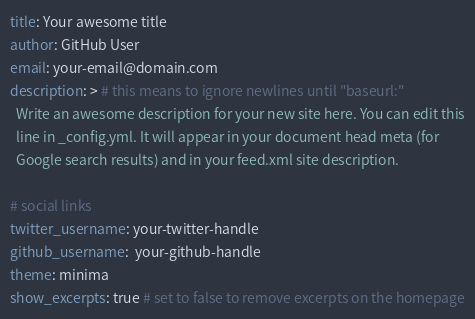<code> <loc_0><loc_0><loc_500><loc_500><_YAML_>title: Your awesome title
author: GitHub User
email: your-email@domain.com
description: > # this means to ignore newlines until "baseurl:"
  Write an awesome description for your new site here. You can edit this
  line in _config.yml. It will appear in your document head meta (for
  Google search results) and in your feed.xml site description.

# social links
twitter_username: your-twitter-handle
github_username:  your-github-handle
theme: minima
show_excerpts: true # set to false to remove excerpts on the homepage
</code> 